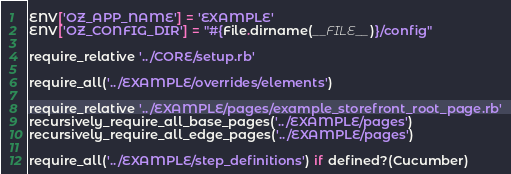<code> <loc_0><loc_0><loc_500><loc_500><_Ruby_>

ENV['OZ_APP_NAME'] = 'EXAMPLE'
ENV['OZ_CONFIG_DIR'] = "#{File.dirname(__FILE__)}/config"

require_relative '../CORE/setup.rb'

require_all('../EXAMPLE/overrides/elements')

require_relative '../EXAMPLE/pages/example_storefront_root_page.rb'
recursively_require_all_base_pages('../EXAMPLE/pages')
recursively_require_all_edge_pages('../EXAMPLE/pages')

require_all('../EXAMPLE/step_definitions') if defined?(Cucumber)</code> 